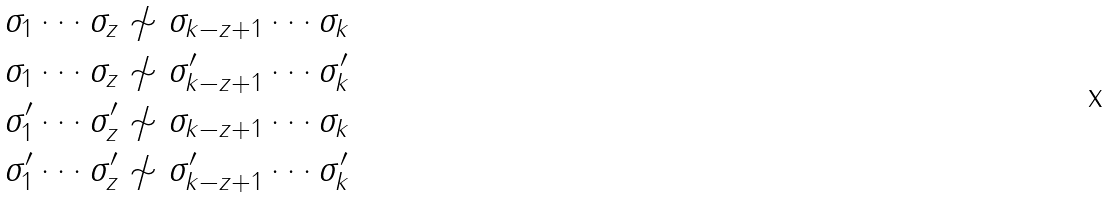<formula> <loc_0><loc_0><loc_500><loc_500>\sigma _ { 1 } \cdots \sigma _ { z } & \not \sim \sigma _ { k - z + 1 } \cdots \sigma _ { k } \\ \sigma _ { 1 } \cdots \sigma _ { z } & \not \sim \sigma _ { k - z + 1 } ^ { \prime } \cdots \sigma _ { k } ^ { \prime } \\ \sigma _ { 1 } ^ { \prime } \cdots \sigma _ { z } ^ { \prime } & \not \sim \sigma _ { k - z + 1 } \cdots \sigma _ { k } \\ \sigma _ { 1 } ^ { \prime } \cdots \sigma _ { z } ^ { \prime } & \not \sim \sigma _ { k - z + 1 } ^ { \prime } \cdots \sigma _ { k } ^ { \prime }</formula> 